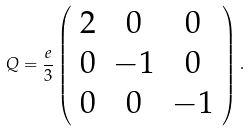<formula> <loc_0><loc_0><loc_500><loc_500>Q = \frac { e } { 3 } \left ( \begin{array} { c c c } 2 & 0 & 0 \\ 0 & - 1 & 0 \\ 0 & 0 & - 1 \end{array} \right ) .</formula> 